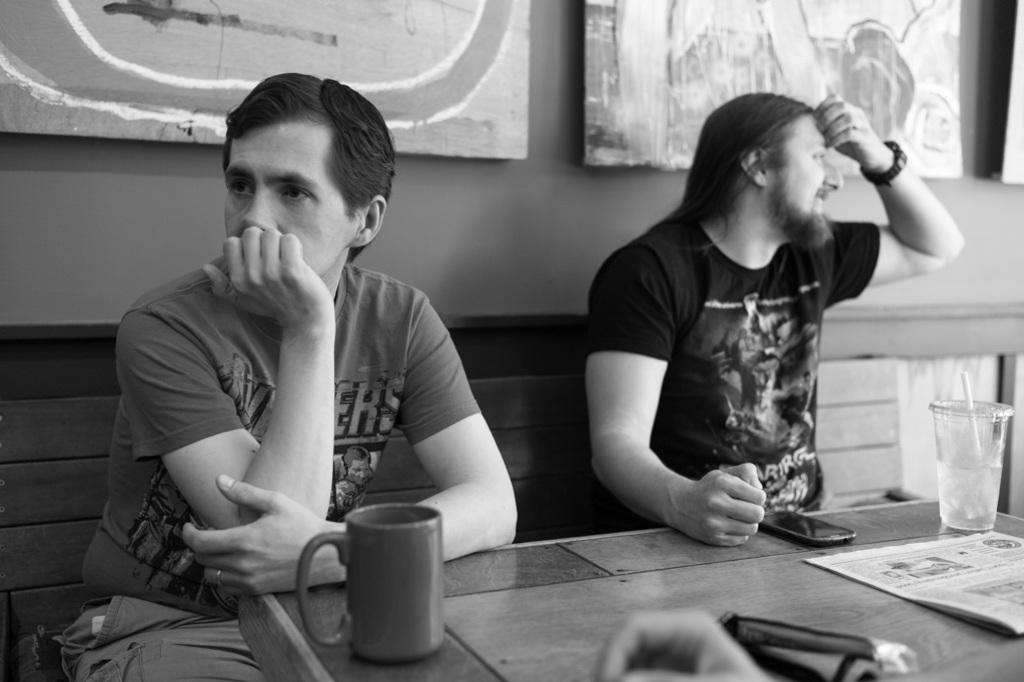Please provide a concise description of this image. In this image I can see there are two men sitting on a bench in front of the table. On the table we have a few objects like glass and cups on it, behind this men we have a wall with some wall photos on it. 